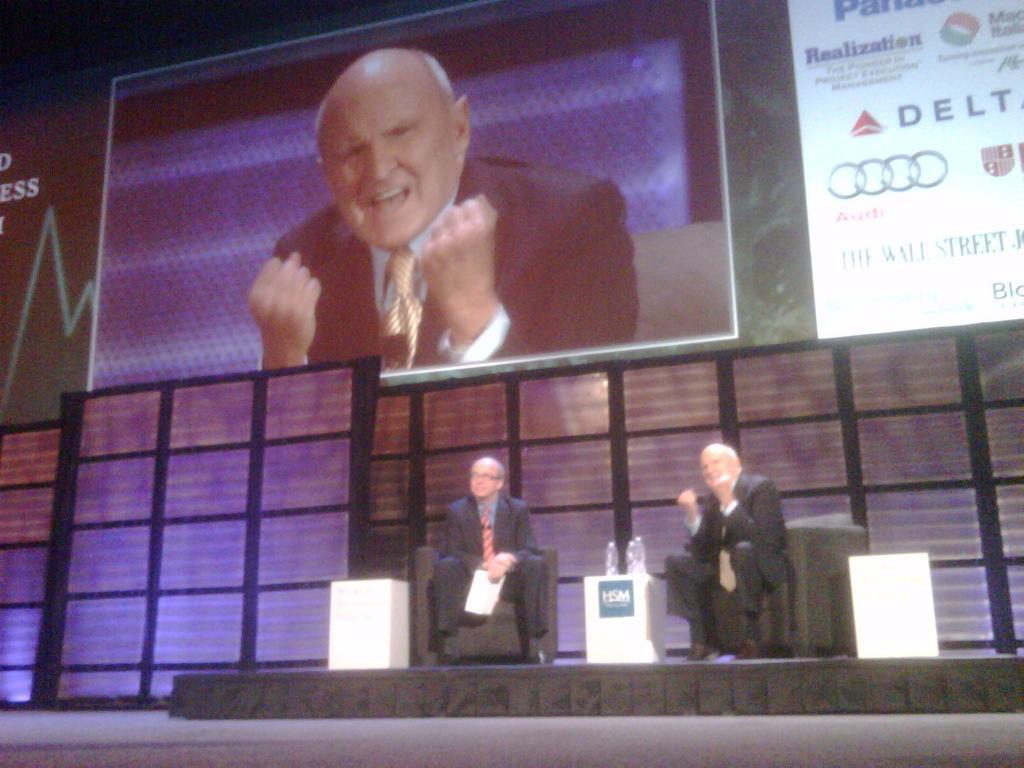In one or two sentences, can you explain what this image depicts? In this image two people are sitting on chairs. Above the table there are bottles. In the background there is a screen and hoardings. On the screen we can see a person.   